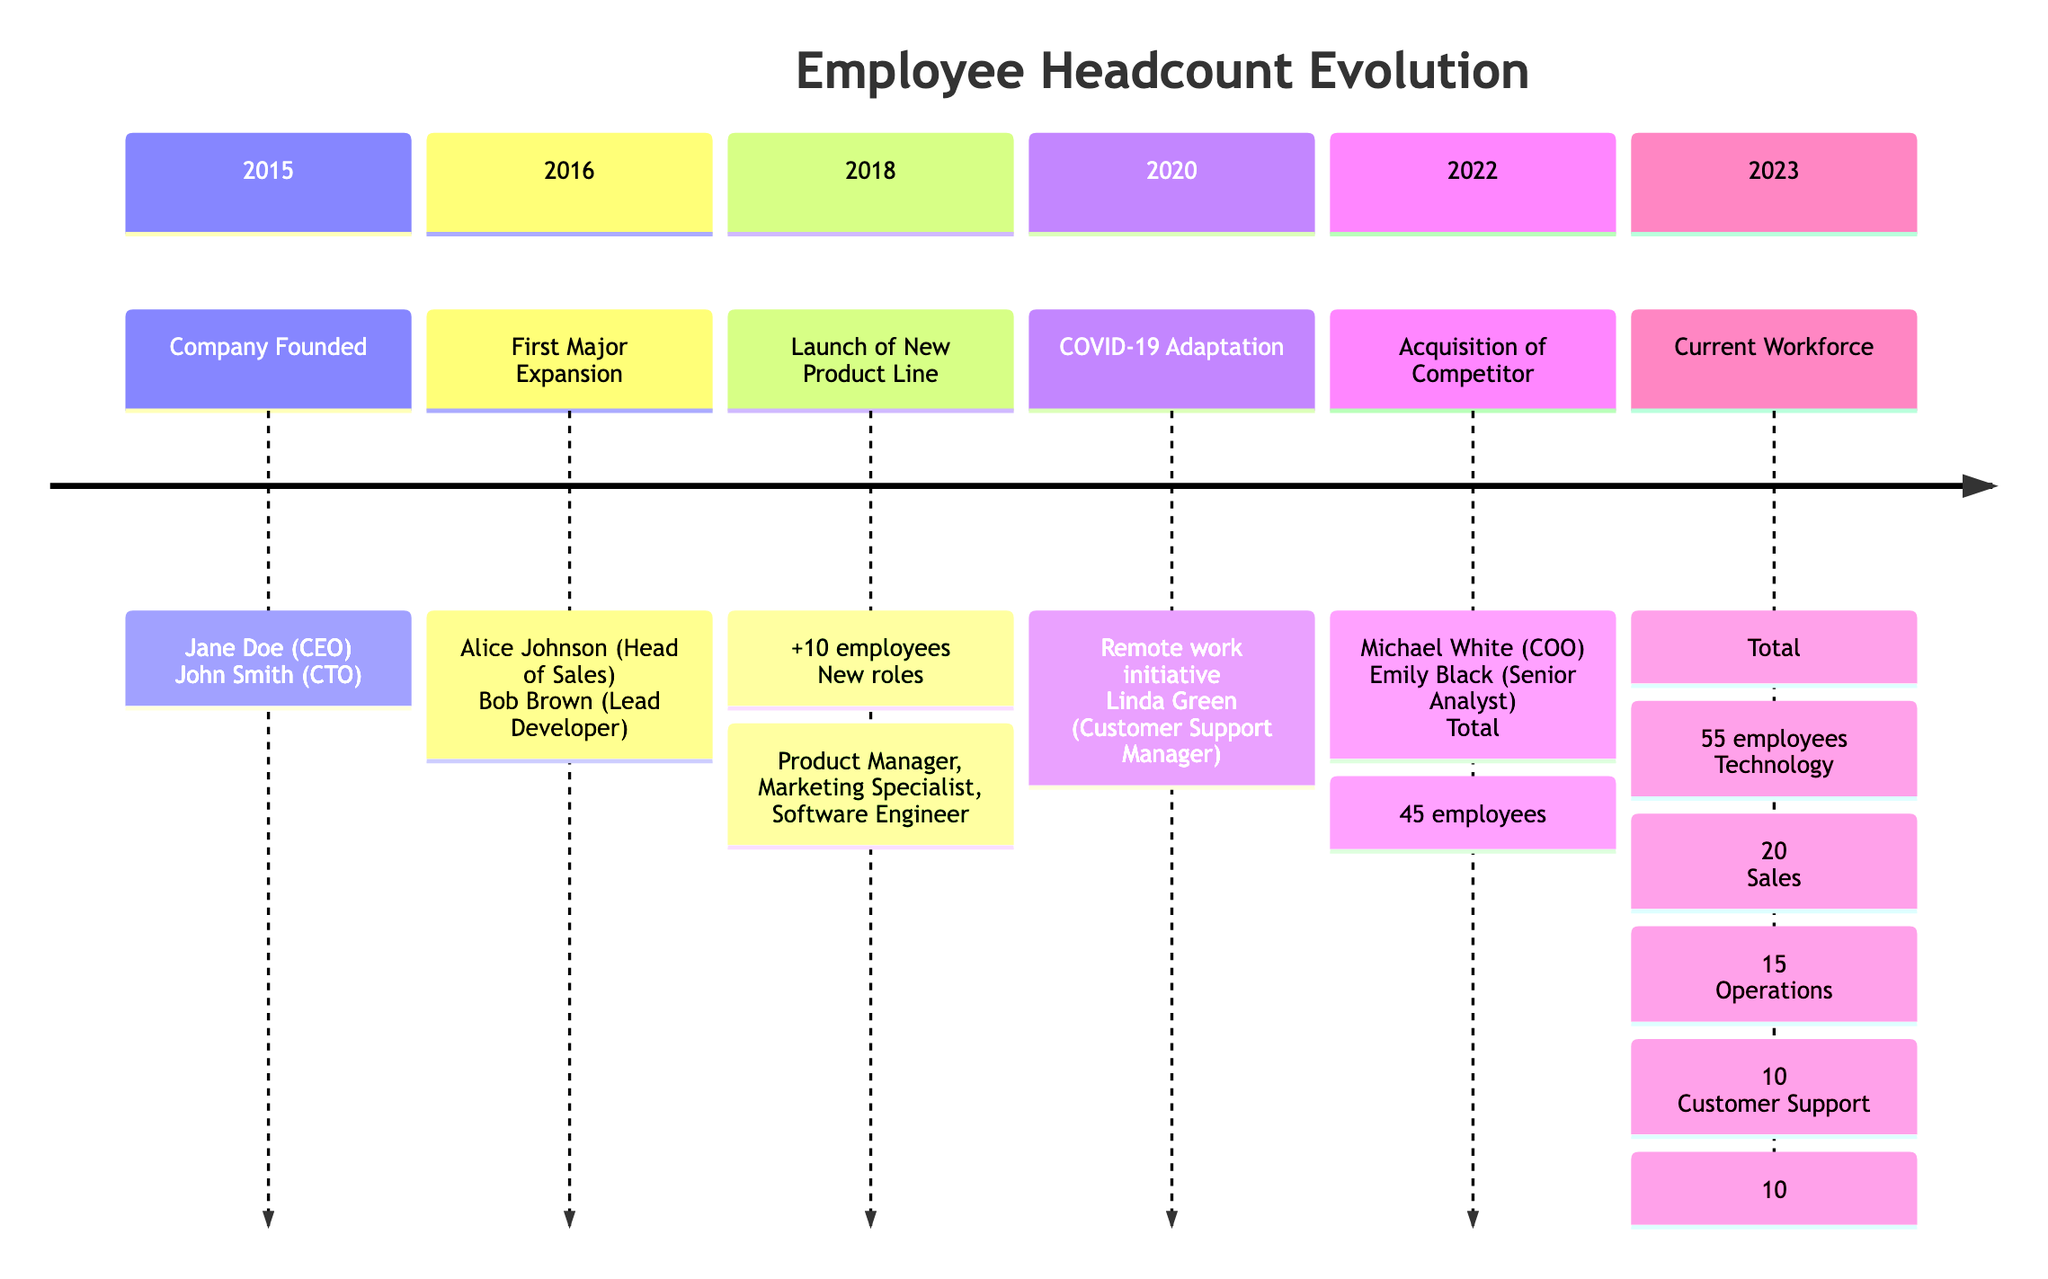What year was the company founded? The founding year is explicitly mentioned in the timeline as 2015.
Answer: 2015 Who was hired as the Head of Sales in 2016? The timeline states that Alice Johnson was hired as the Head of Sales during the first major expansion in 2016.
Answer: Alice Johnson How many employees were added in 2018? The timeline indicates that 10 employees were added when the new product line was launched in 2018.
Answer: 10 What was the total number of employees after the acquisition in 2022? The timeline states that the total number of employees reached 45 after the acquisition of a competitor in 2022.
Answer: 45 Who is the Customer Support Manager as of 2023? The timeline specifies that Linda Green is the Customer Support Manager, reflecting the organizational structure in 2023.
Answer: Linda Green What initiative was introduced in 2020 due to COVID-19? The timeline mentions that a remote work initiative was implemented in response to the COVID-19 pandemic during 2020.
Answer: Remote work initiative Which department had the highest number of employees in 2023? By reviewing the employee distribution in the diagram, the Technology department, with 20 employees, has the highest count as of 2023.
Answer: Technology How many total departments are mentioned in the current workforce structure for 2023? The timeline lists four departments—Technology, Sales, Operations, and Customer Support—indicating the total department count as four.
Answer: 4 Who was the Chief Operating Officer hired in 2022? The timeline lists Michael White as the Chief Operating Officer integrated into the team following the acquisition in 2022.
Answer: Michael White 